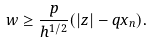Convert formula to latex. <formula><loc_0><loc_0><loc_500><loc_500>w \geq \frac { p } { h ^ { 1 / 2 } } ( | z | - q x _ { n } ) .</formula> 